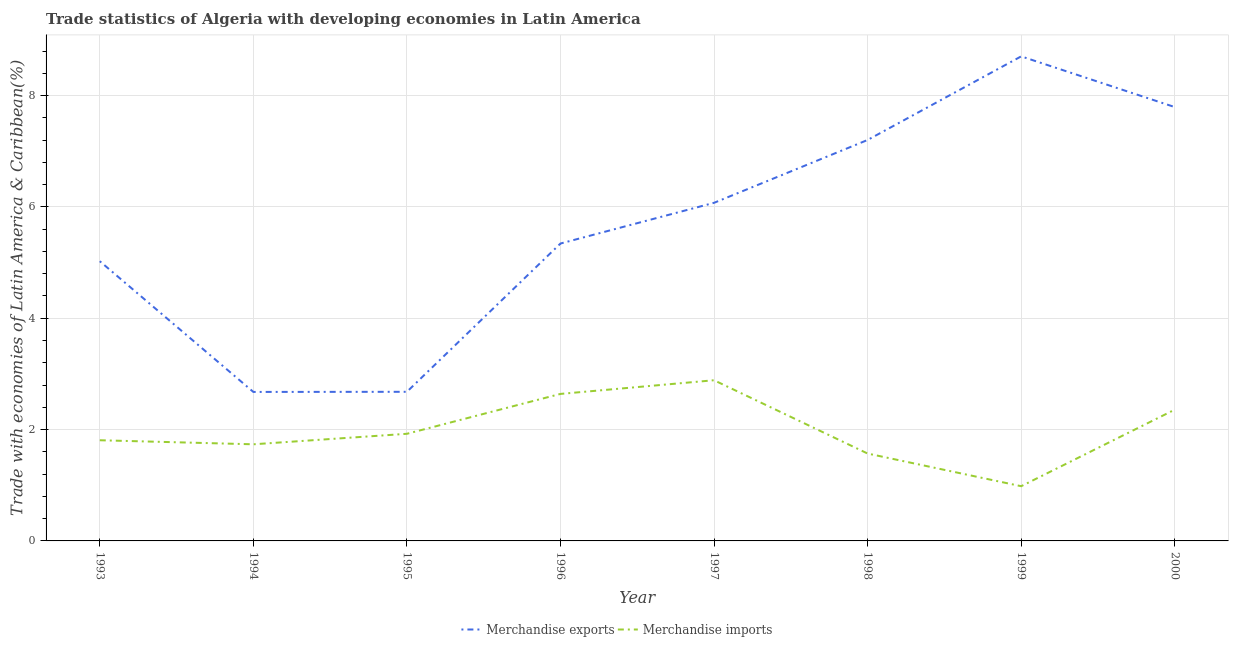How many different coloured lines are there?
Keep it short and to the point. 2. Does the line corresponding to merchandise imports intersect with the line corresponding to merchandise exports?
Make the answer very short. No. Is the number of lines equal to the number of legend labels?
Your response must be concise. Yes. What is the merchandise exports in 1994?
Provide a succinct answer. 2.68. Across all years, what is the maximum merchandise imports?
Ensure brevity in your answer.  2.89. Across all years, what is the minimum merchandise imports?
Make the answer very short. 0.98. In which year was the merchandise imports maximum?
Provide a short and direct response. 1997. What is the total merchandise exports in the graph?
Make the answer very short. 45.5. What is the difference between the merchandise exports in 1994 and that in 1997?
Ensure brevity in your answer.  -3.4. What is the difference between the merchandise exports in 1993 and the merchandise imports in 1997?
Make the answer very short. 2.14. What is the average merchandise exports per year?
Offer a very short reply. 5.69. In the year 1995, what is the difference between the merchandise exports and merchandise imports?
Provide a short and direct response. 0.75. In how many years, is the merchandise imports greater than 2.4 %?
Offer a terse response. 2. What is the ratio of the merchandise exports in 1996 to that in 2000?
Give a very brief answer. 0.69. Is the merchandise exports in 1993 less than that in 1997?
Your answer should be compact. Yes. What is the difference between the highest and the second highest merchandise imports?
Ensure brevity in your answer.  0.25. What is the difference between the highest and the lowest merchandise exports?
Ensure brevity in your answer.  6.03. Does the merchandise exports monotonically increase over the years?
Offer a very short reply. No. Is the merchandise exports strictly greater than the merchandise imports over the years?
Offer a terse response. Yes. How many lines are there?
Make the answer very short. 2. Are the values on the major ticks of Y-axis written in scientific E-notation?
Your answer should be very brief. No. Does the graph contain any zero values?
Your response must be concise. No. How many legend labels are there?
Keep it short and to the point. 2. What is the title of the graph?
Your response must be concise. Trade statistics of Algeria with developing economies in Latin America. Does "Measles" appear as one of the legend labels in the graph?
Give a very brief answer. No. What is the label or title of the Y-axis?
Your response must be concise. Trade with economies of Latin America & Caribbean(%). What is the Trade with economies of Latin America & Caribbean(%) in Merchandise exports in 1993?
Ensure brevity in your answer.  5.02. What is the Trade with economies of Latin America & Caribbean(%) in Merchandise imports in 1993?
Offer a terse response. 1.81. What is the Trade with economies of Latin America & Caribbean(%) in Merchandise exports in 1994?
Make the answer very short. 2.68. What is the Trade with economies of Latin America & Caribbean(%) in Merchandise imports in 1994?
Ensure brevity in your answer.  1.74. What is the Trade with economies of Latin America & Caribbean(%) of Merchandise exports in 1995?
Offer a terse response. 2.68. What is the Trade with economies of Latin America & Caribbean(%) of Merchandise imports in 1995?
Keep it short and to the point. 1.92. What is the Trade with economies of Latin America & Caribbean(%) in Merchandise exports in 1996?
Offer a very short reply. 5.34. What is the Trade with economies of Latin America & Caribbean(%) of Merchandise imports in 1996?
Your response must be concise. 2.64. What is the Trade with economies of Latin America & Caribbean(%) of Merchandise exports in 1997?
Provide a short and direct response. 6.07. What is the Trade with economies of Latin America & Caribbean(%) in Merchandise imports in 1997?
Offer a very short reply. 2.89. What is the Trade with economies of Latin America & Caribbean(%) in Merchandise exports in 1998?
Your answer should be very brief. 7.2. What is the Trade with economies of Latin America & Caribbean(%) of Merchandise imports in 1998?
Your answer should be very brief. 1.57. What is the Trade with economies of Latin America & Caribbean(%) of Merchandise exports in 1999?
Make the answer very short. 8.7. What is the Trade with economies of Latin America & Caribbean(%) of Merchandise imports in 1999?
Offer a very short reply. 0.98. What is the Trade with economies of Latin America & Caribbean(%) in Merchandise exports in 2000?
Offer a very short reply. 7.79. What is the Trade with economies of Latin America & Caribbean(%) in Merchandise imports in 2000?
Provide a short and direct response. 2.36. Across all years, what is the maximum Trade with economies of Latin America & Caribbean(%) in Merchandise exports?
Give a very brief answer. 8.7. Across all years, what is the maximum Trade with economies of Latin America & Caribbean(%) of Merchandise imports?
Ensure brevity in your answer.  2.89. Across all years, what is the minimum Trade with economies of Latin America & Caribbean(%) in Merchandise exports?
Your response must be concise. 2.68. Across all years, what is the minimum Trade with economies of Latin America & Caribbean(%) in Merchandise imports?
Your answer should be compact. 0.98. What is the total Trade with economies of Latin America & Caribbean(%) of Merchandise exports in the graph?
Your response must be concise. 45.5. What is the total Trade with economies of Latin America & Caribbean(%) of Merchandise imports in the graph?
Your answer should be compact. 15.91. What is the difference between the Trade with economies of Latin America & Caribbean(%) in Merchandise exports in 1993 and that in 1994?
Offer a terse response. 2.35. What is the difference between the Trade with economies of Latin America & Caribbean(%) in Merchandise imports in 1993 and that in 1994?
Offer a very short reply. 0.07. What is the difference between the Trade with economies of Latin America & Caribbean(%) in Merchandise exports in 1993 and that in 1995?
Your answer should be very brief. 2.35. What is the difference between the Trade with economies of Latin America & Caribbean(%) in Merchandise imports in 1993 and that in 1995?
Your answer should be compact. -0.12. What is the difference between the Trade with economies of Latin America & Caribbean(%) of Merchandise exports in 1993 and that in 1996?
Offer a terse response. -0.32. What is the difference between the Trade with economies of Latin America & Caribbean(%) of Merchandise imports in 1993 and that in 1996?
Offer a terse response. -0.83. What is the difference between the Trade with economies of Latin America & Caribbean(%) of Merchandise exports in 1993 and that in 1997?
Make the answer very short. -1.05. What is the difference between the Trade with economies of Latin America & Caribbean(%) of Merchandise imports in 1993 and that in 1997?
Keep it short and to the point. -1.08. What is the difference between the Trade with economies of Latin America & Caribbean(%) in Merchandise exports in 1993 and that in 1998?
Your answer should be compact. -2.18. What is the difference between the Trade with economies of Latin America & Caribbean(%) in Merchandise imports in 1993 and that in 1998?
Provide a succinct answer. 0.24. What is the difference between the Trade with economies of Latin America & Caribbean(%) in Merchandise exports in 1993 and that in 1999?
Offer a terse response. -3.68. What is the difference between the Trade with economies of Latin America & Caribbean(%) of Merchandise imports in 1993 and that in 1999?
Offer a very short reply. 0.83. What is the difference between the Trade with economies of Latin America & Caribbean(%) in Merchandise exports in 1993 and that in 2000?
Your answer should be very brief. -2.77. What is the difference between the Trade with economies of Latin America & Caribbean(%) in Merchandise imports in 1993 and that in 2000?
Give a very brief answer. -0.55. What is the difference between the Trade with economies of Latin America & Caribbean(%) in Merchandise exports in 1994 and that in 1995?
Offer a very short reply. -0. What is the difference between the Trade with economies of Latin America & Caribbean(%) in Merchandise imports in 1994 and that in 1995?
Offer a terse response. -0.19. What is the difference between the Trade with economies of Latin America & Caribbean(%) in Merchandise exports in 1994 and that in 1996?
Your response must be concise. -2.67. What is the difference between the Trade with economies of Latin America & Caribbean(%) in Merchandise imports in 1994 and that in 1996?
Your answer should be very brief. -0.91. What is the difference between the Trade with economies of Latin America & Caribbean(%) in Merchandise exports in 1994 and that in 1997?
Your response must be concise. -3.4. What is the difference between the Trade with economies of Latin America & Caribbean(%) of Merchandise imports in 1994 and that in 1997?
Your response must be concise. -1.15. What is the difference between the Trade with economies of Latin America & Caribbean(%) of Merchandise exports in 1994 and that in 1998?
Offer a terse response. -4.53. What is the difference between the Trade with economies of Latin America & Caribbean(%) in Merchandise imports in 1994 and that in 1998?
Your answer should be compact. 0.17. What is the difference between the Trade with economies of Latin America & Caribbean(%) of Merchandise exports in 1994 and that in 1999?
Your answer should be compact. -6.03. What is the difference between the Trade with economies of Latin America & Caribbean(%) in Merchandise imports in 1994 and that in 1999?
Your answer should be very brief. 0.75. What is the difference between the Trade with economies of Latin America & Caribbean(%) in Merchandise exports in 1994 and that in 2000?
Offer a terse response. -5.12. What is the difference between the Trade with economies of Latin America & Caribbean(%) in Merchandise imports in 1994 and that in 2000?
Your answer should be very brief. -0.62. What is the difference between the Trade with economies of Latin America & Caribbean(%) of Merchandise exports in 1995 and that in 1996?
Provide a short and direct response. -2.66. What is the difference between the Trade with economies of Latin America & Caribbean(%) in Merchandise imports in 1995 and that in 1996?
Your answer should be compact. -0.72. What is the difference between the Trade with economies of Latin America & Caribbean(%) of Merchandise exports in 1995 and that in 1997?
Your response must be concise. -3.39. What is the difference between the Trade with economies of Latin America & Caribbean(%) in Merchandise imports in 1995 and that in 1997?
Ensure brevity in your answer.  -0.96. What is the difference between the Trade with economies of Latin America & Caribbean(%) in Merchandise exports in 1995 and that in 1998?
Make the answer very short. -4.52. What is the difference between the Trade with economies of Latin America & Caribbean(%) of Merchandise imports in 1995 and that in 1998?
Offer a terse response. 0.35. What is the difference between the Trade with economies of Latin America & Caribbean(%) of Merchandise exports in 1995 and that in 1999?
Your response must be concise. -6.03. What is the difference between the Trade with economies of Latin America & Caribbean(%) in Merchandise imports in 1995 and that in 1999?
Provide a succinct answer. 0.94. What is the difference between the Trade with economies of Latin America & Caribbean(%) in Merchandise exports in 1995 and that in 2000?
Provide a succinct answer. -5.12. What is the difference between the Trade with economies of Latin America & Caribbean(%) of Merchandise imports in 1995 and that in 2000?
Give a very brief answer. -0.43. What is the difference between the Trade with economies of Latin America & Caribbean(%) of Merchandise exports in 1996 and that in 1997?
Your answer should be compact. -0.73. What is the difference between the Trade with economies of Latin America & Caribbean(%) of Merchandise imports in 1996 and that in 1997?
Offer a terse response. -0.25. What is the difference between the Trade with economies of Latin America & Caribbean(%) of Merchandise exports in 1996 and that in 1998?
Offer a very short reply. -1.86. What is the difference between the Trade with economies of Latin America & Caribbean(%) in Merchandise imports in 1996 and that in 1998?
Your response must be concise. 1.07. What is the difference between the Trade with economies of Latin America & Caribbean(%) of Merchandise exports in 1996 and that in 1999?
Provide a short and direct response. -3.36. What is the difference between the Trade with economies of Latin America & Caribbean(%) in Merchandise imports in 1996 and that in 1999?
Keep it short and to the point. 1.66. What is the difference between the Trade with economies of Latin America & Caribbean(%) of Merchandise exports in 1996 and that in 2000?
Offer a very short reply. -2.45. What is the difference between the Trade with economies of Latin America & Caribbean(%) in Merchandise imports in 1996 and that in 2000?
Your answer should be compact. 0.28. What is the difference between the Trade with economies of Latin America & Caribbean(%) in Merchandise exports in 1997 and that in 1998?
Give a very brief answer. -1.13. What is the difference between the Trade with economies of Latin America & Caribbean(%) of Merchandise imports in 1997 and that in 1998?
Offer a very short reply. 1.32. What is the difference between the Trade with economies of Latin America & Caribbean(%) in Merchandise exports in 1997 and that in 1999?
Offer a very short reply. -2.63. What is the difference between the Trade with economies of Latin America & Caribbean(%) of Merchandise imports in 1997 and that in 1999?
Give a very brief answer. 1.9. What is the difference between the Trade with economies of Latin America & Caribbean(%) of Merchandise exports in 1997 and that in 2000?
Offer a very short reply. -1.72. What is the difference between the Trade with economies of Latin America & Caribbean(%) in Merchandise imports in 1997 and that in 2000?
Your answer should be compact. 0.53. What is the difference between the Trade with economies of Latin America & Caribbean(%) in Merchandise exports in 1998 and that in 1999?
Your answer should be very brief. -1.5. What is the difference between the Trade with economies of Latin America & Caribbean(%) of Merchandise imports in 1998 and that in 1999?
Offer a very short reply. 0.59. What is the difference between the Trade with economies of Latin America & Caribbean(%) in Merchandise exports in 1998 and that in 2000?
Your answer should be compact. -0.59. What is the difference between the Trade with economies of Latin America & Caribbean(%) of Merchandise imports in 1998 and that in 2000?
Your answer should be compact. -0.79. What is the difference between the Trade with economies of Latin America & Caribbean(%) of Merchandise exports in 1999 and that in 2000?
Your answer should be compact. 0.91. What is the difference between the Trade with economies of Latin America & Caribbean(%) in Merchandise imports in 1999 and that in 2000?
Your answer should be very brief. -1.38. What is the difference between the Trade with economies of Latin America & Caribbean(%) of Merchandise exports in 1993 and the Trade with economies of Latin America & Caribbean(%) of Merchandise imports in 1994?
Your response must be concise. 3.29. What is the difference between the Trade with economies of Latin America & Caribbean(%) of Merchandise exports in 1993 and the Trade with economies of Latin America & Caribbean(%) of Merchandise imports in 1995?
Your answer should be compact. 3.1. What is the difference between the Trade with economies of Latin America & Caribbean(%) of Merchandise exports in 1993 and the Trade with economies of Latin America & Caribbean(%) of Merchandise imports in 1996?
Provide a short and direct response. 2.38. What is the difference between the Trade with economies of Latin America & Caribbean(%) of Merchandise exports in 1993 and the Trade with economies of Latin America & Caribbean(%) of Merchandise imports in 1997?
Keep it short and to the point. 2.14. What is the difference between the Trade with economies of Latin America & Caribbean(%) in Merchandise exports in 1993 and the Trade with economies of Latin America & Caribbean(%) in Merchandise imports in 1998?
Give a very brief answer. 3.46. What is the difference between the Trade with economies of Latin America & Caribbean(%) of Merchandise exports in 1993 and the Trade with economies of Latin America & Caribbean(%) of Merchandise imports in 1999?
Ensure brevity in your answer.  4.04. What is the difference between the Trade with economies of Latin America & Caribbean(%) in Merchandise exports in 1993 and the Trade with economies of Latin America & Caribbean(%) in Merchandise imports in 2000?
Provide a succinct answer. 2.67. What is the difference between the Trade with economies of Latin America & Caribbean(%) of Merchandise exports in 1994 and the Trade with economies of Latin America & Caribbean(%) of Merchandise imports in 1995?
Make the answer very short. 0.75. What is the difference between the Trade with economies of Latin America & Caribbean(%) in Merchandise exports in 1994 and the Trade with economies of Latin America & Caribbean(%) in Merchandise imports in 1996?
Ensure brevity in your answer.  0.04. What is the difference between the Trade with economies of Latin America & Caribbean(%) in Merchandise exports in 1994 and the Trade with economies of Latin America & Caribbean(%) in Merchandise imports in 1997?
Your answer should be very brief. -0.21. What is the difference between the Trade with economies of Latin America & Caribbean(%) of Merchandise exports in 1994 and the Trade with economies of Latin America & Caribbean(%) of Merchandise imports in 1998?
Offer a very short reply. 1.11. What is the difference between the Trade with economies of Latin America & Caribbean(%) in Merchandise exports in 1994 and the Trade with economies of Latin America & Caribbean(%) in Merchandise imports in 1999?
Offer a very short reply. 1.69. What is the difference between the Trade with economies of Latin America & Caribbean(%) of Merchandise exports in 1994 and the Trade with economies of Latin America & Caribbean(%) of Merchandise imports in 2000?
Offer a terse response. 0.32. What is the difference between the Trade with economies of Latin America & Caribbean(%) in Merchandise exports in 1995 and the Trade with economies of Latin America & Caribbean(%) in Merchandise imports in 1996?
Your answer should be very brief. 0.04. What is the difference between the Trade with economies of Latin America & Caribbean(%) of Merchandise exports in 1995 and the Trade with economies of Latin America & Caribbean(%) of Merchandise imports in 1997?
Offer a very short reply. -0.21. What is the difference between the Trade with economies of Latin America & Caribbean(%) of Merchandise exports in 1995 and the Trade with economies of Latin America & Caribbean(%) of Merchandise imports in 1998?
Offer a terse response. 1.11. What is the difference between the Trade with economies of Latin America & Caribbean(%) of Merchandise exports in 1995 and the Trade with economies of Latin America & Caribbean(%) of Merchandise imports in 1999?
Your response must be concise. 1.7. What is the difference between the Trade with economies of Latin America & Caribbean(%) in Merchandise exports in 1995 and the Trade with economies of Latin America & Caribbean(%) in Merchandise imports in 2000?
Your answer should be very brief. 0.32. What is the difference between the Trade with economies of Latin America & Caribbean(%) in Merchandise exports in 1996 and the Trade with economies of Latin America & Caribbean(%) in Merchandise imports in 1997?
Give a very brief answer. 2.46. What is the difference between the Trade with economies of Latin America & Caribbean(%) in Merchandise exports in 1996 and the Trade with economies of Latin America & Caribbean(%) in Merchandise imports in 1998?
Your answer should be compact. 3.77. What is the difference between the Trade with economies of Latin America & Caribbean(%) of Merchandise exports in 1996 and the Trade with economies of Latin America & Caribbean(%) of Merchandise imports in 1999?
Your answer should be very brief. 4.36. What is the difference between the Trade with economies of Latin America & Caribbean(%) of Merchandise exports in 1996 and the Trade with economies of Latin America & Caribbean(%) of Merchandise imports in 2000?
Your answer should be compact. 2.98. What is the difference between the Trade with economies of Latin America & Caribbean(%) of Merchandise exports in 1997 and the Trade with economies of Latin America & Caribbean(%) of Merchandise imports in 1998?
Give a very brief answer. 4.5. What is the difference between the Trade with economies of Latin America & Caribbean(%) of Merchandise exports in 1997 and the Trade with economies of Latin America & Caribbean(%) of Merchandise imports in 1999?
Ensure brevity in your answer.  5.09. What is the difference between the Trade with economies of Latin America & Caribbean(%) in Merchandise exports in 1997 and the Trade with economies of Latin America & Caribbean(%) in Merchandise imports in 2000?
Your answer should be compact. 3.72. What is the difference between the Trade with economies of Latin America & Caribbean(%) in Merchandise exports in 1998 and the Trade with economies of Latin America & Caribbean(%) in Merchandise imports in 1999?
Keep it short and to the point. 6.22. What is the difference between the Trade with economies of Latin America & Caribbean(%) in Merchandise exports in 1998 and the Trade with economies of Latin America & Caribbean(%) in Merchandise imports in 2000?
Offer a terse response. 4.84. What is the difference between the Trade with economies of Latin America & Caribbean(%) of Merchandise exports in 1999 and the Trade with economies of Latin America & Caribbean(%) of Merchandise imports in 2000?
Your answer should be compact. 6.35. What is the average Trade with economies of Latin America & Caribbean(%) in Merchandise exports per year?
Keep it short and to the point. 5.69. What is the average Trade with economies of Latin America & Caribbean(%) of Merchandise imports per year?
Ensure brevity in your answer.  1.99. In the year 1993, what is the difference between the Trade with economies of Latin America & Caribbean(%) in Merchandise exports and Trade with economies of Latin America & Caribbean(%) in Merchandise imports?
Give a very brief answer. 3.22. In the year 1994, what is the difference between the Trade with economies of Latin America & Caribbean(%) of Merchandise exports and Trade with economies of Latin America & Caribbean(%) of Merchandise imports?
Your response must be concise. 0.94. In the year 1995, what is the difference between the Trade with economies of Latin America & Caribbean(%) of Merchandise exports and Trade with economies of Latin America & Caribbean(%) of Merchandise imports?
Your response must be concise. 0.75. In the year 1996, what is the difference between the Trade with economies of Latin America & Caribbean(%) of Merchandise exports and Trade with economies of Latin America & Caribbean(%) of Merchandise imports?
Offer a terse response. 2.7. In the year 1997, what is the difference between the Trade with economies of Latin America & Caribbean(%) in Merchandise exports and Trade with economies of Latin America & Caribbean(%) in Merchandise imports?
Provide a short and direct response. 3.19. In the year 1998, what is the difference between the Trade with economies of Latin America & Caribbean(%) in Merchandise exports and Trade with economies of Latin America & Caribbean(%) in Merchandise imports?
Make the answer very short. 5.63. In the year 1999, what is the difference between the Trade with economies of Latin America & Caribbean(%) in Merchandise exports and Trade with economies of Latin America & Caribbean(%) in Merchandise imports?
Your answer should be compact. 7.72. In the year 2000, what is the difference between the Trade with economies of Latin America & Caribbean(%) in Merchandise exports and Trade with economies of Latin America & Caribbean(%) in Merchandise imports?
Your response must be concise. 5.44. What is the ratio of the Trade with economies of Latin America & Caribbean(%) in Merchandise exports in 1993 to that in 1994?
Provide a short and direct response. 1.88. What is the ratio of the Trade with economies of Latin America & Caribbean(%) in Merchandise imports in 1993 to that in 1994?
Your response must be concise. 1.04. What is the ratio of the Trade with economies of Latin America & Caribbean(%) of Merchandise exports in 1993 to that in 1995?
Your answer should be compact. 1.88. What is the ratio of the Trade with economies of Latin America & Caribbean(%) in Merchandise imports in 1993 to that in 1995?
Provide a succinct answer. 0.94. What is the ratio of the Trade with economies of Latin America & Caribbean(%) in Merchandise exports in 1993 to that in 1996?
Give a very brief answer. 0.94. What is the ratio of the Trade with economies of Latin America & Caribbean(%) in Merchandise imports in 1993 to that in 1996?
Keep it short and to the point. 0.68. What is the ratio of the Trade with economies of Latin America & Caribbean(%) in Merchandise exports in 1993 to that in 1997?
Keep it short and to the point. 0.83. What is the ratio of the Trade with economies of Latin America & Caribbean(%) in Merchandise imports in 1993 to that in 1997?
Your answer should be very brief. 0.63. What is the ratio of the Trade with economies of Latin America & Caribbean(%) in Merchandise exports in 1993 to that in 1998?
Offer a very short reply. 0.7. What is the ratio of the Trade with economies of Latin America & Caribbean(%) of Merchandise imports in 1993 to that in 1998?
Your answer should be very brief. 1.15. What is the ratio of the Trade with economies of Latin America & Caribbean(%) of Merchandise exports in 1993 to that in 1999?
Provide a short and direct response. 0.58. What is the ratio of the Trade with economies of Latin America & Caribbean(%) in Merchandise imports in 1993 to that in 1999?
Make the answer very short. 1.84. What is the ratio of the Trade with economies of Latin America & Caribbean(%) of Merchandise exports in 1993 to that in 2000?
Make the answer very short. 0.64. What is the ratio of the Trade with economies of Latin America & Caribbean(%) in Merchandise imports in 1993 to that in 2000?
Keep it short and to the point. 0.77. What is the ratio of the Trade with economies of Latin America & Caribbean(%) in Merchandise imports in 1994 to that in 1995?
Provide a succinct answer. 0.9. What is the ratio of the Trade with economies of Latin America & Caribbean(%) of Merchandise exports in 1994 to that in 1996?
Provide a succinct answer. 0.5. What is the ratio of the Trade with economies of Latin America & Caribbean(%) of Merchandise imports in 1994 to that in 1996?
Ensure brevity in your answer.  0.66. What is the ratio of the Trade with economies of Latin America & Caribbean(%) in Merchandise exports in 1994 to that in 1997?
Keep it short and to the point. 0.44. What is the ratio of the Trade with economies of Latin America & Caribbean(%) in Merchandise imports in 1994 to that in 1997?
Your response must be concise. 0.6. What is the ratio of the Trade with economies of Latin America & Caribbean(%) in Merchandise exports in 1994 to that in 1998?
Ensure brevity in your answer.  0.37. What is the ratio of the Trade with economies of Latin America & Caribbean(%) of Merchandise imports in 1994 to that in 1998?
Provide a succinct answer. 1.11. What is the ratio of the Trade with economies of Latin America & Caribbean(%) of Merchandise exports in 1994 to that in 1999?
Offer a very short reply. 0.31. What is the ratio of the Trade with economies of Latin America & Caribbean(%) in Merchandise imports in 1994 to that in 1999?
Ensure brevity in your answer.  1.77. What is the ratio of the Trade with economies of Latin America & Caribbean(%) of Merchandise exports in 1994 to that in 2000?
Your answer should be compact. 0.34. What is the ratio of the Trade with economies of Latin America & Caribbean(%) in Merchandise imports in 1994 to that in 2000?
Offer a terse response. 0.74. What is the ratio of the Trade with economies of Latin America & Caribbean(%) in Merchandise exports in 1995 to that in 1996?
Ensure brevity in your answer.  0.5. What is the ratio of the Trade with economies of Latin America & Caribbean(%) of Merchandise imports in 1995 to that in 1996?
Your answer should be compact. 0.73. What is the ratio of the Trade with economies of Latin America & Caribbean(%) of Merchandise exports in 1995 to that in 1997?
Your answer should be compact. 0.44. What is the ratio of the Trade with economies of Latin America & Caribbean(%) of Merchandise imports in 1995 to that in 1997?
Your response must be concise. 0.67. What is the ratio of the Trade with economies of Latin America & Caribbean(%) in Merchandise exports in 1995 to that in 1998?
Offer a very short reply. 0.37. What is the ratio of the Trade with economies of Latin America & Caribbean(%) in Merchandise imports in 1995 to that in 1998?
Provide a succinct answer. 1.23. What is the ratio of the Trade with economies of Latin America & Caribbean(%) of Merchandise exports in 1995 to that in 1999?
Keep it short and to the point. 0.31. What is the ratio of the Trade with economies of Latin America & Caribbean(%) of Merchandise imports in 1995 to that in 1999?
Offer a very short reply. 1.96. What is the ratio of the Trade with economies of Latin America & Caribbean(%) in Merchandise exports in 1995 to that in 2000?
Your answer should be compact. 0.34. What is the ratio of the Trade with economies of Latin America & Caribbean(%) of Merchandise imports in 1995 to that in 2000?
Your response must be concise. 0.82. What is the ratio of the Trade with economies of Latin America & Caribbean(%) of Merchandise exports in 1996 to that in 1997?
Offer a very short reply. 0.88. What is the ratio of the Trade with economies of Latin America & Caribbean(%) of Merchandise imports in 1996 to that in 1997?
Offer a terse response. 0.92. What is the ratio of the Trade with economies of Latin America & Caribbean(%) of Merchandise exports in 1996 to that in 1998?
Ensure brevity in your answer.  0.74. What is the ratio of the Trade with economies of Latin America & Caribbean(%) of Merchandise imports in 1996 to that in 1998?
Provide a short and direct response. 1.68. What is the ratio of the Trade with economies of Latin America & Caribbean(%) in Merchandise exports in 1996 to that in 1999?
Give a very brief answer. 0.61. What is the ratio of the Trade with economies of Latin America & Caribbean(%) in Merchandise imports in 1996 to that in 1999?
Offer a terse response. 2.69. What is the ratio of the Trade with economies of Latin America & Caribbean(%) of Merchandise exports in 1996 to that in 2000?
Your answer should be very brief. 0.69. What is the ratio of the Trade with economies of Latin America & Caribbean(%) of Merchandise imports in 1996 to that in 2000?
Provide a succinct answer. 1.12. What is the ratio of the Trade with economies of Latin America & Caribbean(%) in Merchandise exports in 1997 to that in 1998?
Offer a terse response. 0.84. What is the ratio of the Trade with economies of Latin America & Caribbean(%) of Merchandise imports in 1997 to that in 1998?
Your answer should be compact. 1.84. What is the ratio of the Trade with economies of Latin America & Caribbean(%) of Merchandise exports in 1997 to that in 1999?
Provide a succinct answer. 0.7. What is the ratio of the Trade with economies of Latin America & Caribbean(%) of Merchandise imports in 1997 to that in 1999?
Give a very brief answer. 2.94. What is the ratio of the Trade with economies of Latin America & Caribbean(%) in Merchandise exports in 1997 to that in 2000?
Make the answer very short. 0.78. What is the ratio of the Trade with economies of Latin America & Caribbean(%) in Merchandise imports in 1997 to that in 2000?
Offer a very short reply. 1.22. What is the ratio of the Trade with economies of Latin America & Caribbean(%) in Merchandise exports in 1998 to that in 1999?
Give a very brief answer. 0.83. What is the ratio of the Trade with economies of Latin America & Caribbean(%) of Merchandise imports in 1998 to that in 1999?
Give a very brief answer. 1.6. What is the ratio of the Trade with economies of Latin America & Caribbean(%) of Merchandise exports in 1998 to that in 2000?
Your answer should be very brief. 0.92. What is the ratio of the Trade with economies of Latin America & Caribbean(%) in Merchandise imports in 1998 to that in 2000?
Your response must be concise. 0.67. What is the ratio of the Trade with economies of Latin America & Caribbean(%) in Merchandise exports in 1999 to that in 2000?
Your answer should be compact. 1.12. What is the ratio of the Trade with economies of Latin America & Caribbean(%) of Merchandise imports in 1999 to that in 2000?
Your answer should be compact. 0.42. What is the difference between the highest and the second highest Trade with economies of Latin America & Caribbean(%) of Merchandise exports?
Make the answer very short. 0.91. What is the difference between the highest and the second highest Trade with economies of Latin America & Caribbean(%) of Merchandise imports?
Provide a succinct answer. 0.25. What is the difference between the highest and the lowest Trade with economies of Latin America & Caribbean(%) of Merchandise exports?
Your response must be concise. 6.03. What is the difference between the highest and the lowest Trade with economies of Latin America & Caribbean(%) of Merchandise imports?
Offer a terse response. 1.9. 